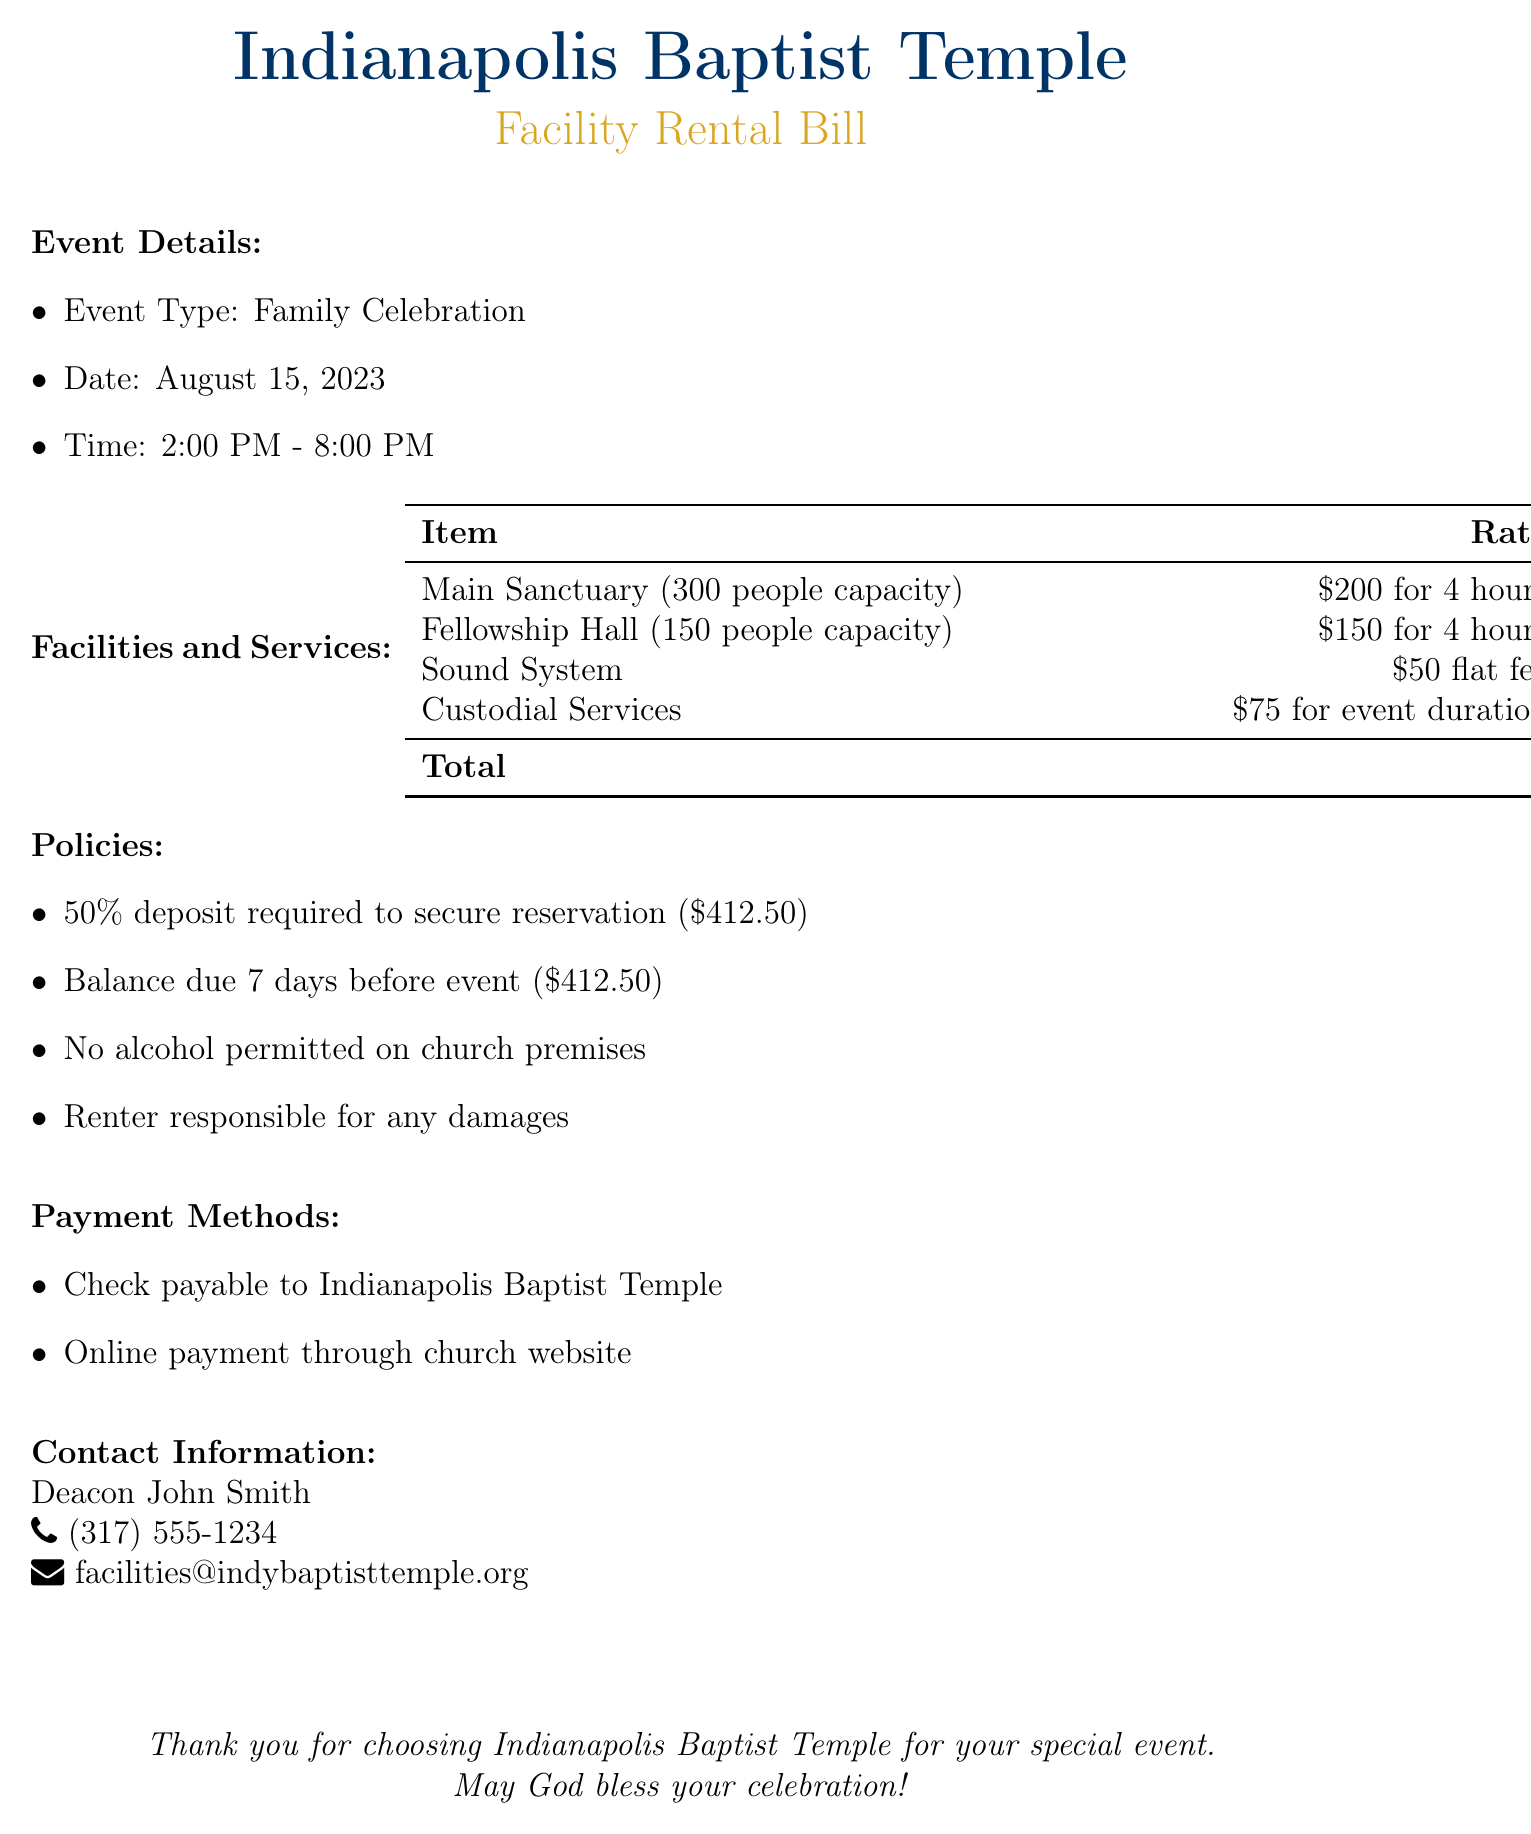What is the event type? The event type is specified in the document under Event Details.
Answer: Family Celebration What is the date of the event? The date is provided in the Event Details section.
Answer: August 15, 2023 What is the total rental fee? The total rental fee is calculated at the bottom of the Facilities and Services section.
Answer: $825.00 What is the deposit required to secure the reservation? The required deposit is mentioned in the Policies section.
Answer: $412.50 How many people can the Main Sanctuary accommodate? The capacity of the Main Sanctuary is stated in the Facilities and Services section.
Answer: 300 people What is the payment method provided for online transactions? The document mentions the payment method under Payment Methods.
Answer: Online payment through church website What is the custodial services fee? The fee for custodial services is listed in the Facilities and Services table.
Answer: $75.00 Is alcohol permitted on the church premises? The document specifies policies regarding alcohol in the Policies section.
Answer: No Who should checks be payable to? The payment methods section specifies who checks should be made out to.
Answer: Indianapolis Baptist Temple 